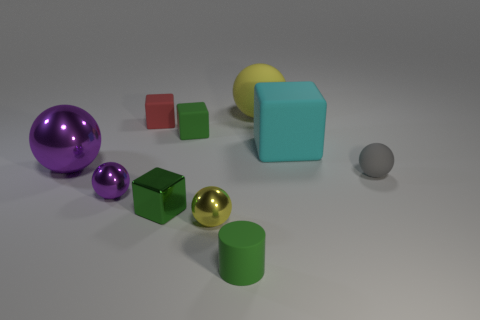Is there a metallic block that is behind the rubber sphere that is in front of the big yellow rubber thing?
Provide a succinct answer. No. There is a rubber ball right of the large ball that is on the right side of the tiny yellow object; how many yellow balls are in front of it?
Your answer should be compact. 1. Is the number of green rubber cubes less than the number of yellow metallic cubes?
Provide a short and direct response. No. Is the shape of the big thing left of the tiny green matte cube the same as the cyan matte object on the right side of the tiny purple thing?
Provide a succinct answer. No. The big metal object is what color?
Your answer should be compact. Purple. How many metallic things are either green things or small purple objects?
Your response must be concise. 2. The other rubber object that is the same shape as the gray matte object is what color?
Your answer should be very brief. Yellow. Are there any cylinders?
Offer a terse response. Yes. Does the small green block behind the gray rubber thing have the same material as the purple ball in front of the tiny gray rubber sphere?
Make the answer very short. No. There is a rubber object that is the same color as the tiny matte cylinder; what shape is it?
Give a very brief answer. Cube. 